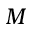Convert formula to latex. <formula><loc_0><loc_0><loc_500><loc_500>M</formula> 